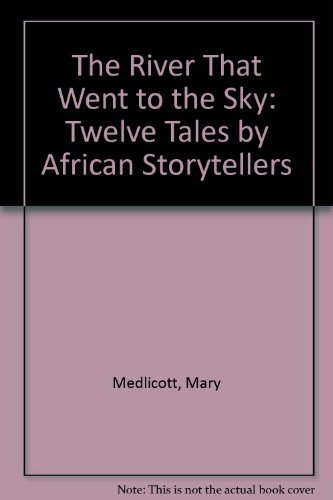Can you describe the themes explored in this book? This book explores themes of adventure, cultural heritage, and moral lessons, each woven into tales from various African traditions to delight and teach young readers. 